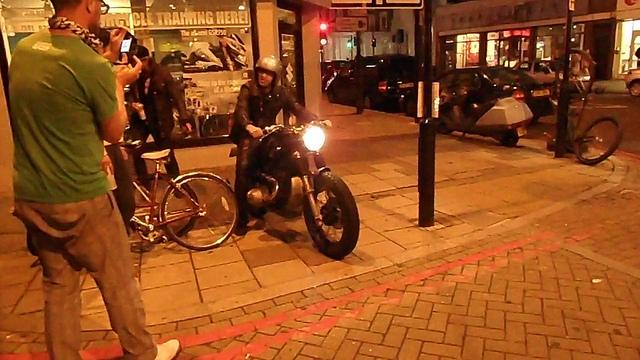What is aimed at the man on the motorcycle? camera 